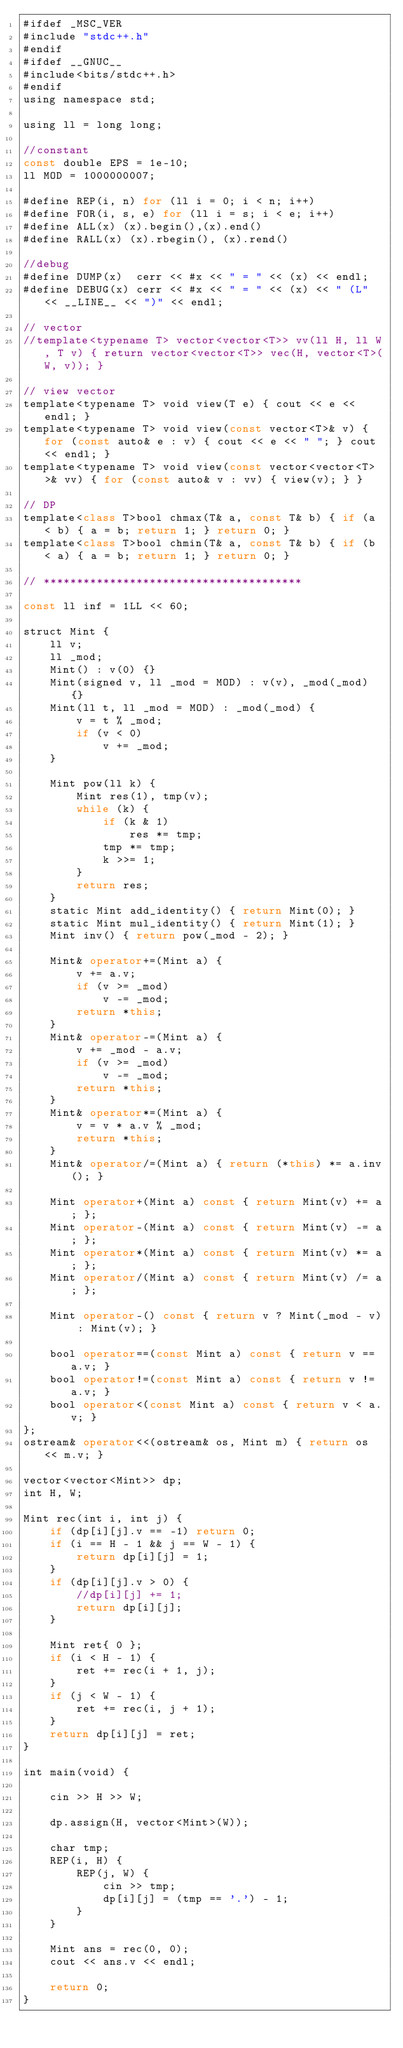<code> <loc_0><loc_0><loc_500><loc_500><_Kotlin_>#ifdef _MSC_VER
#include "stdc++.h"
#endif
#ifdef __GNUC__
#include<bits/stdc++.h>
#endif
using namespace std;

using ll = long long;

//constant
const double EPS = 1e-10;
ll MOD = 1000000007;

#define REP(i, n) for (ll i = 0; i < n; i++)
#define FOR(i, s, e) for (ll i = s; i < e; i++)
#define ALL(x) (x).begin(),(x).end()
#define RALL(x) (x).rbegin(), (x).rend()

//debug
#define DUMP(x)  cerr << #x << " = " << (x) << endl;
#define DEBUG(x) cerr << #x << " = " << (x) << " (L" << __LINE__ << ")" << endl;

// vector
//template<typename T> vector<vector<T>> vv(ll H, ll W, T v) { return vector<vector<T>> vec(H, vector<T>(W, v)); }

// view vector
template<typename T> void view(T e) { cout << e << endl; }
template<typename T> void view(const vector<T>& v) { for (const auto& e : v) { cout << e << " "; } cout << endl; }
template<typename T> void view(const vector<vector<T> >& vv) { for (const auto& v : vv) { view(v); } }

// DP
template<class T>bool chmax(T& a, const T& b) { if (a < b) { a = b; return 1; } return 0; }
template<class T>bool chmin(T& a, const T& b) { if (b < a) { a = b; return 1; } return 0; }

// ***************************************

const ll inf = 1LL << 60;

struct Mint {
    ll v;
    ll _mod;
    Mint() : v(0) {}
    Mint(signed v, ll _mod = MOD) : v(v), _mod(_mod) {}
    Mint(ll t, ll _mod = MOD) : _mod(_mod) {
        v = t % _mod;
        if (v < 0)
            v += _mod;
    }

    Mint pow(ll k) {
        Mint res(1), tmp(v);
        while (k) {
            if (k & 1)
                res *= tmp;
            tmp *= tmp;
            k >>= 1;
        }
        return res;
    }
    static Mint add_identity() { return Mint(0); }
    static Mint mul_identity() { return Mint(1); }
    Mint inv() { return pow(_mod - 2); }

    Mint& operator+=(Mint a) {
        v += a.v;
        if (v >= _mod)
            v -= _mod;
        return *this;
    }
    Mint& operator-=(Mint a) {
        v += _mod - a.v;
        if (v >= _mod)
            v -= _mod;
        return *this;
    }
    Mint& operator*=(Mint a) {
        v = v * a.v % _mod;
        return *this;
    }
    Mint& operator/=(Mint a) { return (*this) *= a.inv(); }

    Mint operator+(Mint a) const { return Mint(v) += a; };
    Mint operator-(Mint a) const { return Mint(v) -= a; };
    Mint operator*(Mint a) const { return Mint(v) *= a; };
    Mint operator/(Mint a) const { return Mint(v) /= a; };

    Mint operator-() const { return v ? Mint(_mod - v) : Mint(v); }

    bool operator==(const Mint a) const { return v == a.v; }
    bool operator!=(const Mint a) const { return v != a.v; }
    bool operator<(const Mint a) const { return v < a.v; }
};
ostream& operator<<(ostream& os, Mint m) { return os << m.v; }

vector<vector<Mint>> dp;
int H, W;

Mint rec(int i, int j) {
    if (dp[i][j].v == -1) return 0;
    if (i == H - 1 && j == W - 1) {
        return dp[i][j] = 1;
    }
    if (dp[i][j].v > 0) {
        //dp[i][j] += 1;
        return dp[i][j];
    }

    Mint ret{ 0 };
    if (i < H - 1) {
        ret += rec(i + 1, j);
    }
    if (j < W - 1) {
        ret += rec(i, j + 1);
    }
    return dp[i][j] = ret;
}

int main(void) {

	cin >> H >> W;

    dp.assign(H, vector<Mint>(W));

    char tmp;
    REP(i, H) {
        REP(j, W) {
            cin >> tmp;
            dp[i][j] = (tmp == '.') - 1;
        }
    }

    Mint ans = rec(0, 0);
    cout << ans.v << endl;

	return 0;
}</code> 